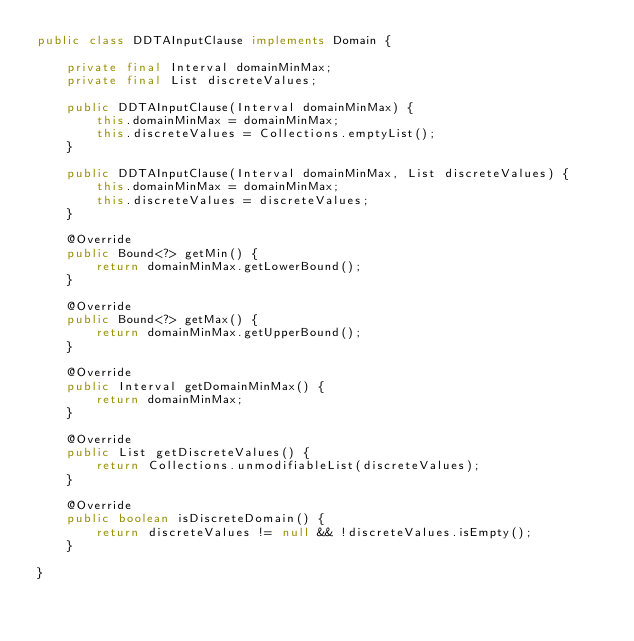<code> <loc_0><loc_0><loc_500><loc_500><_Java_>public class DDTAInputClause implements Domain {

    private final Interval domainMinMax;
    private final List discreteValues;

    public DDTAInputClause(Interval domainMinMax) {
        this.domainMinMax = domainMinMax;
        this.discreteValues = Collections.emptyList();
    }

    public DDTAInputClause(Interval domainMinMax, List discreteValues) {
        this.domainMinMax = domainMinMax;
        this.discreteValues = discreteValues;
    }

    @Override
    public Bound<?> getMin() {
        return domainMinMax.getLowerBound();
    }

    @Override
    public Bound<?> getMax() {
        return domainMinMax.getUpperBound();
    }

    @Override
    public Interval getDomainMinMax() {
        return domainMinMax;
    }

    @Override
    public List getDiscreteValues() {
        return Collections.unmodifiableList(discreteValues);
    }

    @Override
    public boolean isDiscreteDomain() {
        return discreteValues != null && !discreteValues.isEmpty();
    }

}
</code> 